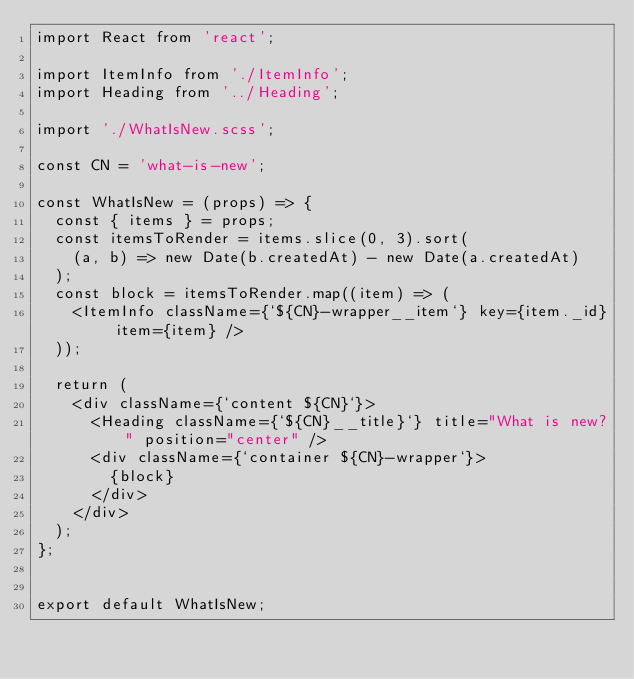<code> <loc_0><loc_0><loc_500><loc_500><_JavaScript_>import React from 'react';

import ItemInfo from './ItemInfo';
import Heading from '../Heading';

import './WhatIsNew.scss';

const CN = 'what-is-new';

const WhatIsNew = (props) => {
  const { items } = props;
  const itemsToRender = items.slice(0, 3).sort(
    (a, b) => new Date(b.createdAt) - new Date(a.createdAt)
  );
  const block = itemsToRender.map((item) => (
    <ItemInfo className={`${CN}-wrapper__item`} key={item._id} item={item} />
  ));

  return (
    <div className={`content ${CN}`}>
      <Heading className={`${CN}__title}`} title="What is new?" position="center" />
      <div className={`container ${CN}-wrapper`}>
        {block}
      </div>
    </div>
  );
};


export default WhatIsNew;
</code> 